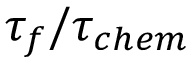Convert formula to latex. <formula><loc_0><loc_0><loc_500><loc_500>\tau _ { f } / \tau _ { c h e m }</formula> 